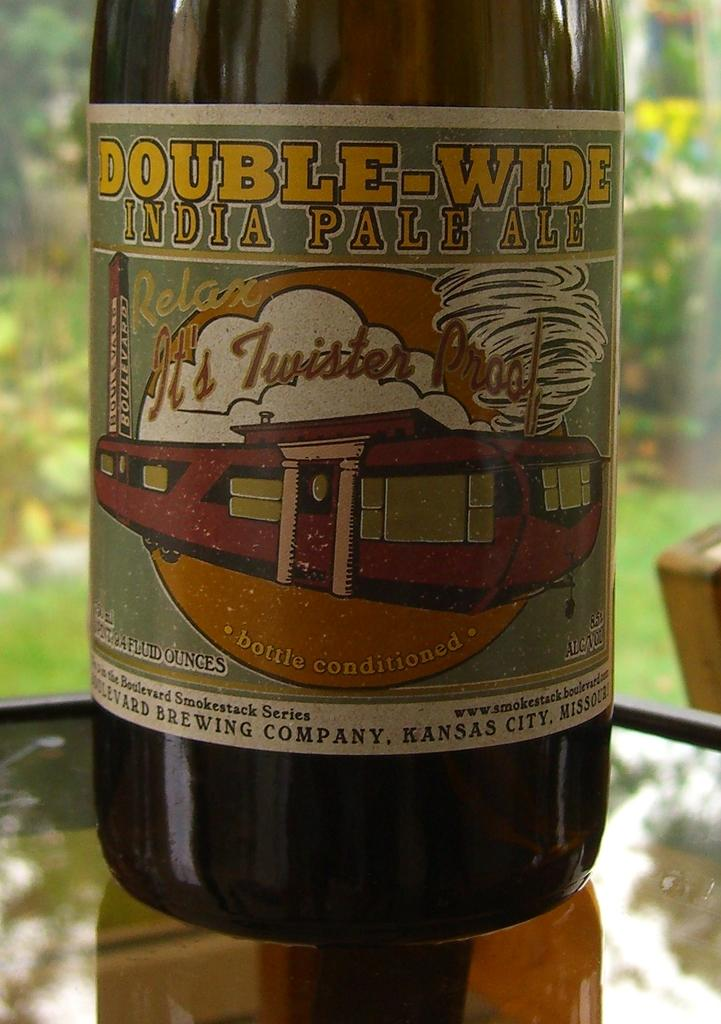<image>
Offer a succinct explanation of the picture presented. A dark beer bottle labled "Double-Wide India Pale Ale" with a graphic proclaiming "Relax, It's Twister Proof" over an image of a mobile home with tornado in the background. 